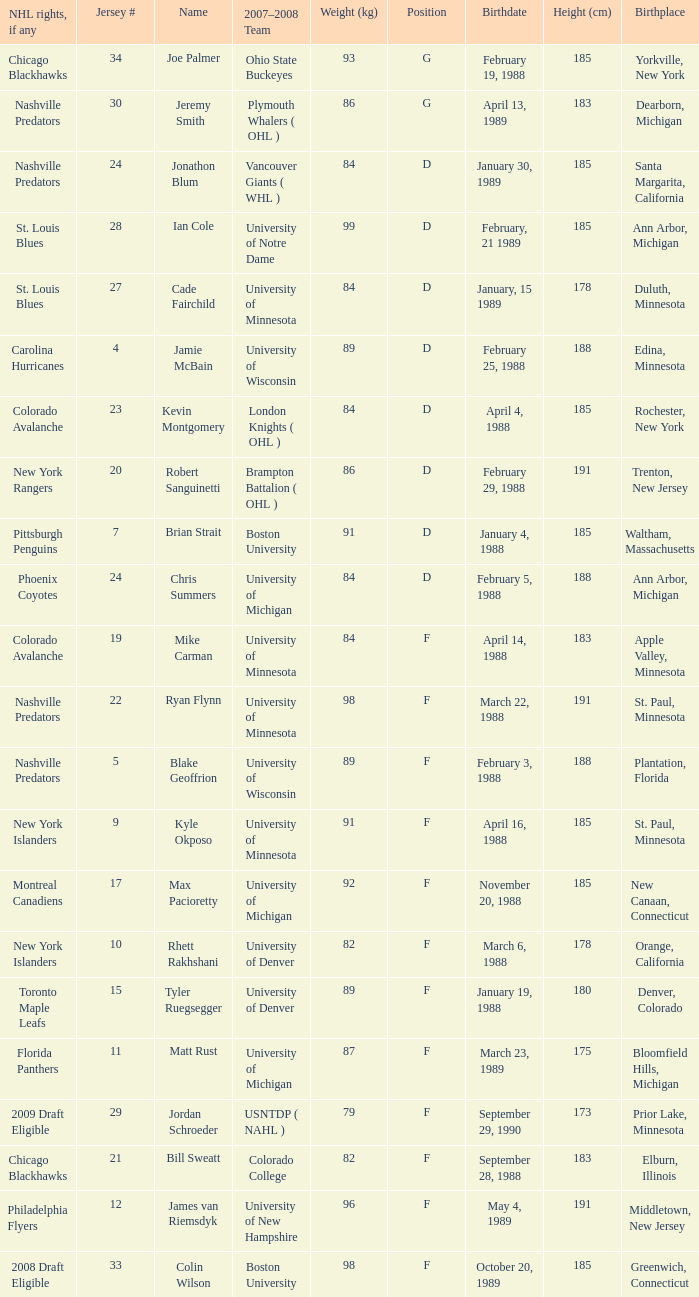From bloomfield hills, michigan, what height in centimeters is a person likely to have? 175.0. 